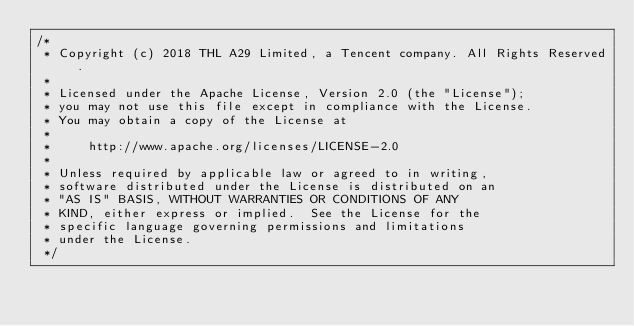<code> <loc_0><loc_0><loc_500><loc_500><_C#_>/*
 * Copyright (c) 2018 THL A29 Limited, a Tencent company. All Rights Reserved.
 *
 * Licensed under the Apache License, Version 2.0 (the "License");
 * you may not use this file except in compliance with the License.
 * You may obtain a copy of the License at
 *
 *     http://www.apache.org/licenses/LICENSE-2.0
 *
 * Unless required by applicable law or agreed to in writing,
 * software distributed under the License is distributed on an
 * "AS IS" BASIS, WITHOUT WARRANTIES OR CONDITIONS OF ANY
 * KIND, either express or implied.  See the License for the
 * specific language governing permissions and limitations
 * under the License.
 */
</code> 